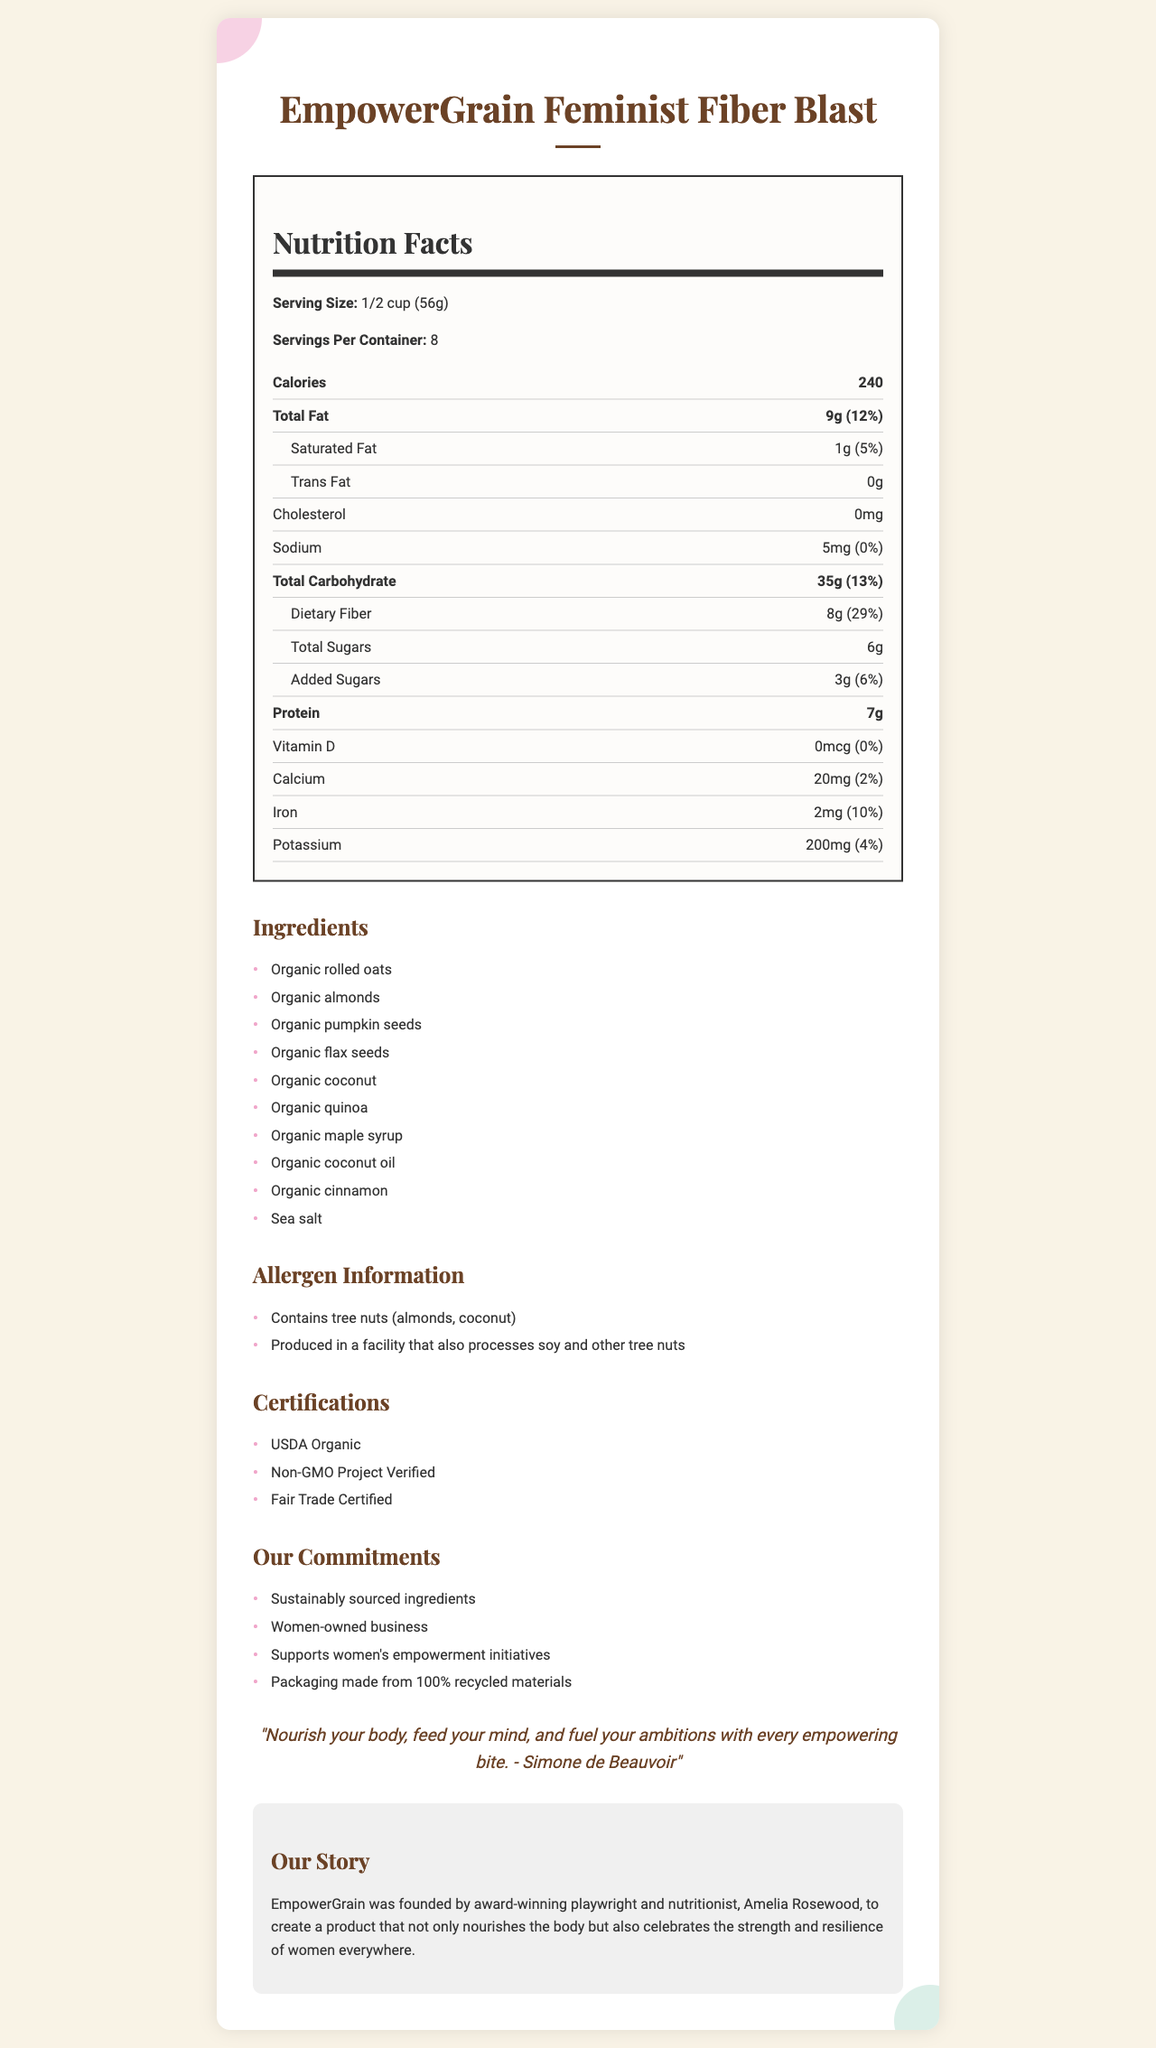what is the serving size for EmpowerGrain Feminist Fiber Blast? The serving size is clearly stated at the beginning of the Nutrition Facts section as "1/2 cup (56g)".
Answer: 1/2 cup (56g) how many servings are there per container? The document specifies that there are 8 servings per container.
Answer: 8 how much dietary fiber does one serving provide? The amount of dietary fiber per serving is listed as "8g" in the Total Carbohydrate section of the Nutrition Facts.
Answer: 8g what is the percent daily value of protein per serving? It only lists the amount of protein as "7g" without indicating its percent daily value.
Answer: The document does not specify the percent daily value for protein. which of the following certifications does the product have? A. USDA Organic B. Non-GMO Project Verified C. Fair Trade Certified D. All of the above The product holds all these certifications: USDA Organic, Non-GMO Project Verified, and Fair Trade Certified.
Answer: D what are the main marketing claims made about EmpowerGrain Feminist Fiber Blast? These claims are listed under the "Our Commitments" section.
Answer: Sustainably sourced ingredients, Women-owned business, Supports women's empowerment initiatives, Packaging made from 100% recycled materials does the product contain added sugars? The document lists "Added Sugars" with an amount of 3g, indicating the product does contain added sugars.
Answer: Yes how much iron does one serving provide? The amount of iron per serving is detailed in the Nutrition Facts section as "2mg".
Answer: 2mg what allergens does EmpowerGrain Feminist Fiber Blast contain? The allergen information section specifies that the product contains tree nuts (almonds, coconut).
Answer: Tree nuts (almonds, coconut) is the product produced in a facility that processes soy? The allergen information mentions that the product is produced in a facility that also processes soy.
Answer: Yes Identify a feminist-themed element in the document. This quote embodies feminist themes by emphasizing empowerment and is attributed to a prominent feminist philosopher.
Answer: The quote: "Nourish your body, feed your mind, and fuel your ambitions with every empowering bite. - Simone de Beauvoir" summarize the entire document. The document is structured to communicate both the nutritional value and the broader ethical and empowerment-focused mission of the product.
Answer: The document provides detailed information about EmpowerGrain Feminist Fiber Blast, a high-fiber granola aimed at empowered, health-conscious women. It includes nutrition facts, ingredients, allergen warnings, certifications, marketing claims, a feminist-themed quote, and a brand story emphasizing women's empowerment and sustainability. how much saturated fat does the product contain per serving? The Nutrition Facts section lists the amount of saturated fat as "1g" per serving.
Answer: 1g what is the brand story behind EmpowerGrain? The brand story section clearly states the founder and the mission behind the brand.
Answer: EmpowerGrain was founded by award-winning playwright and nutritionist, Amelia Rosewood, to create a product that not only nourishes the body but also celebrates the strength and resilience of women everywhere. Does the granola contain any cholesterol? The Nutrition Facts indicate that the amount of cholesterol is "0mg", meaning there is no cholesterol in the product.
Answer: No what is the total carbohydrate content in one serving? In the Nutrition Facts section, total carbohydrate content per serving is listed as "35g".
Answer: 35g who founded EmpowerGrain? The brand story specifies that EmpowerGrain was founded by Amelia Rosewood, an award-winning playwright and nutritionist.
Answer: Amelia Rosewood 